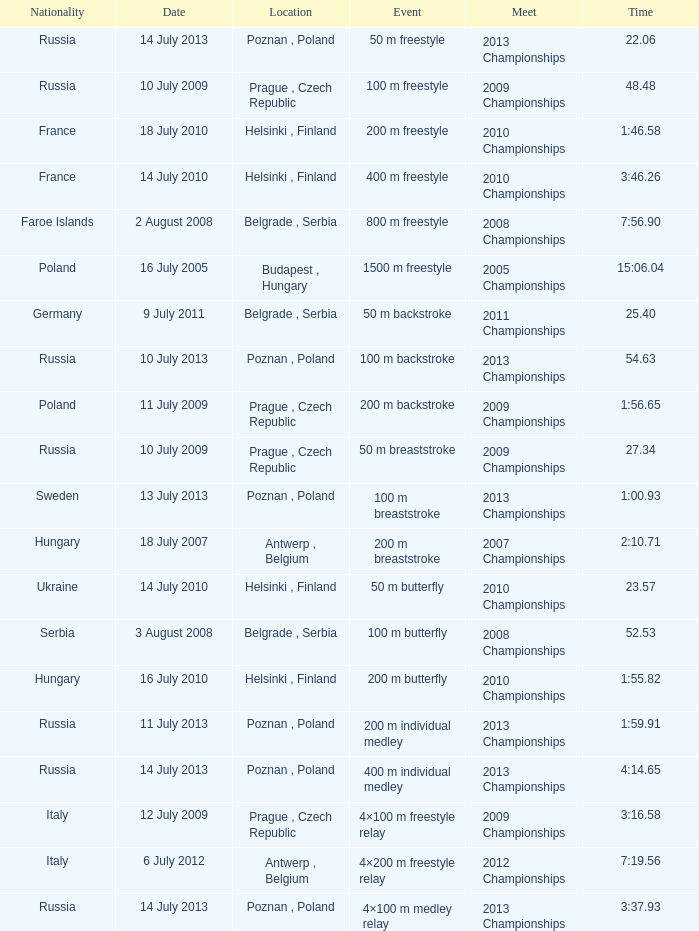What date was the 1500 m freestyle competition? 16 July 2005. 